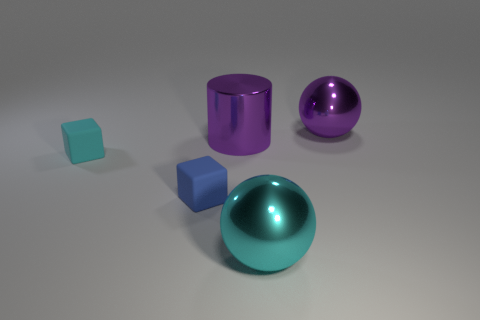What is the approximate ratio of the sizes between the cyan cube and the blue cube? The cyan cube appears to be approximately half the size of the blue cube in terms of height, width, and depth, suggesting a size ratio of about 1:8 in volume if we assume they have the same proportionality in all three dimensions. 